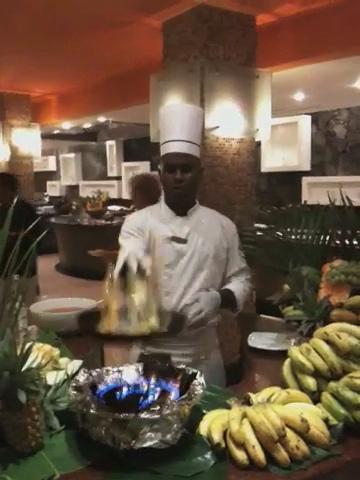How many people are visible?
Give a very brief answer. 1. How many bananas can you see?
Give a very brief answer. 2. 